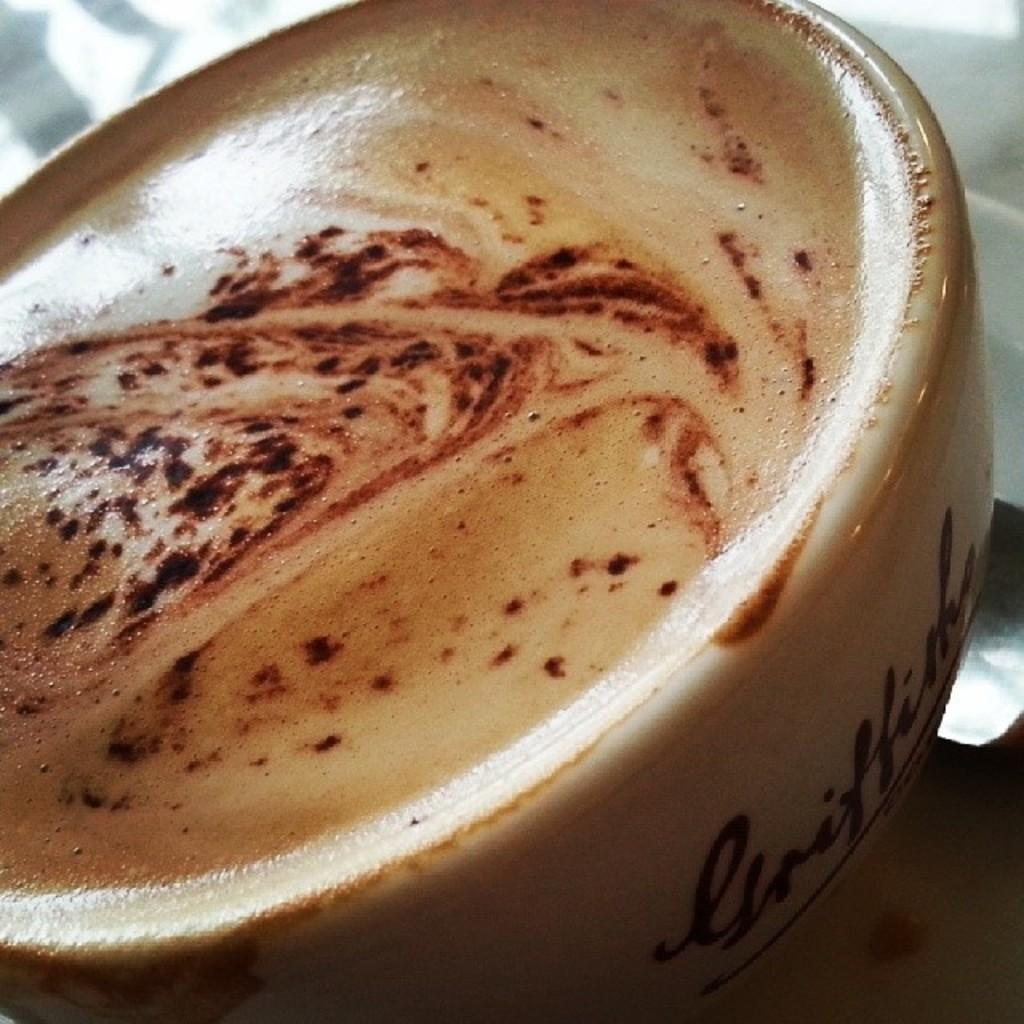What is present in the image? There is a coffee cup in the image. What is the coffee cup placed on? The coffee cup is on an object. What type of blood can be seen coming from the coffee cup in the image? There is no blood present in the image; it is a coffee cup. What scent is associated with the coffee cup in the image? The image does not provide information about the scent of the coffee cup. 